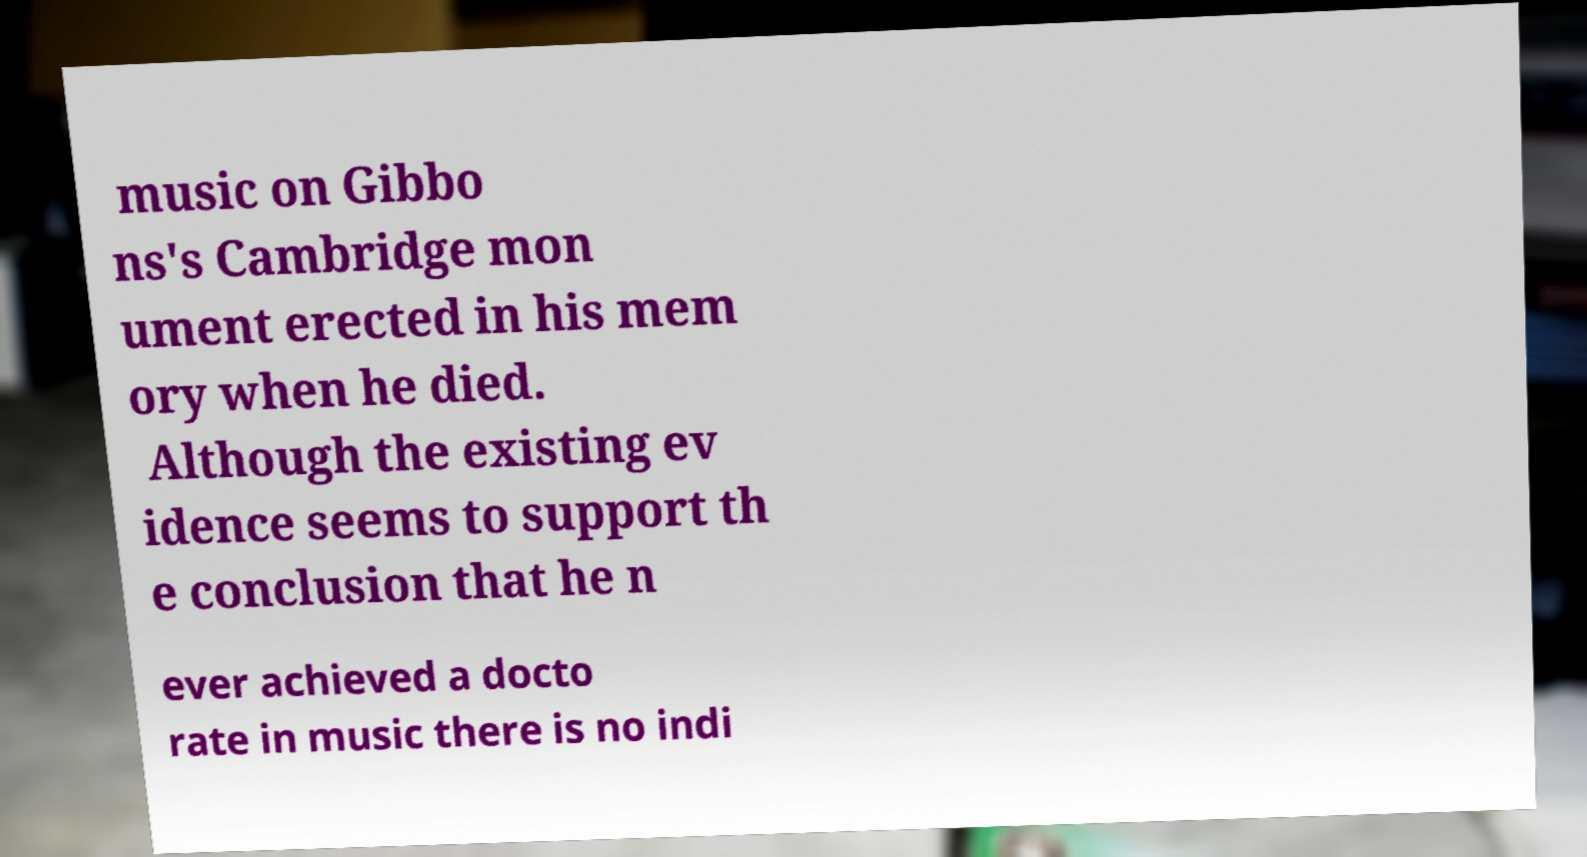Please read and relay the text visible in this image. What does it say? music on Gibbo ns's Cambridge mon ument erected in his mem ory when he died. Although the existing ev idence seems to support th e conclusion that he n ever achieved a docto rate in music there is no indi 